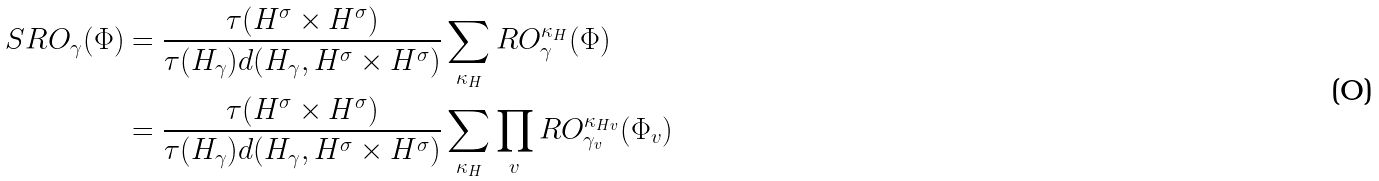Convert formula to latex. <formula><loc_0><loc_0><loc_500><loc_500>S R O _ { \gamma } ( \Phi ) & = \frac { \tau ( H ^ { \sigma } \times H ^ { \sigma } ) } { \tau ( H _ { \gamma } ) d ( H _ { \gamma } , H ^ { \sigma } \times H ^ { \sigma } ) } \sum _ { \kappa _ { H } } R O ^ { \kappa _ { H } } _ { \gamma } ( \Phi ) \\ & = \frac { \tau ( H ^ { \sigma } \times H ^ { \sigma } ) } { \tau ( H _ { \gamma } ) d ( H _ { \gamma } , H ^ { \sigma } \times H ^ { \sigma } ) } \sum _ { \kappa _ { H } } \prod _ { v } R O ^ { \kappa _ { H v } } _ { \gamma _ { v } } ( \Phi _ { v } )</formula> 